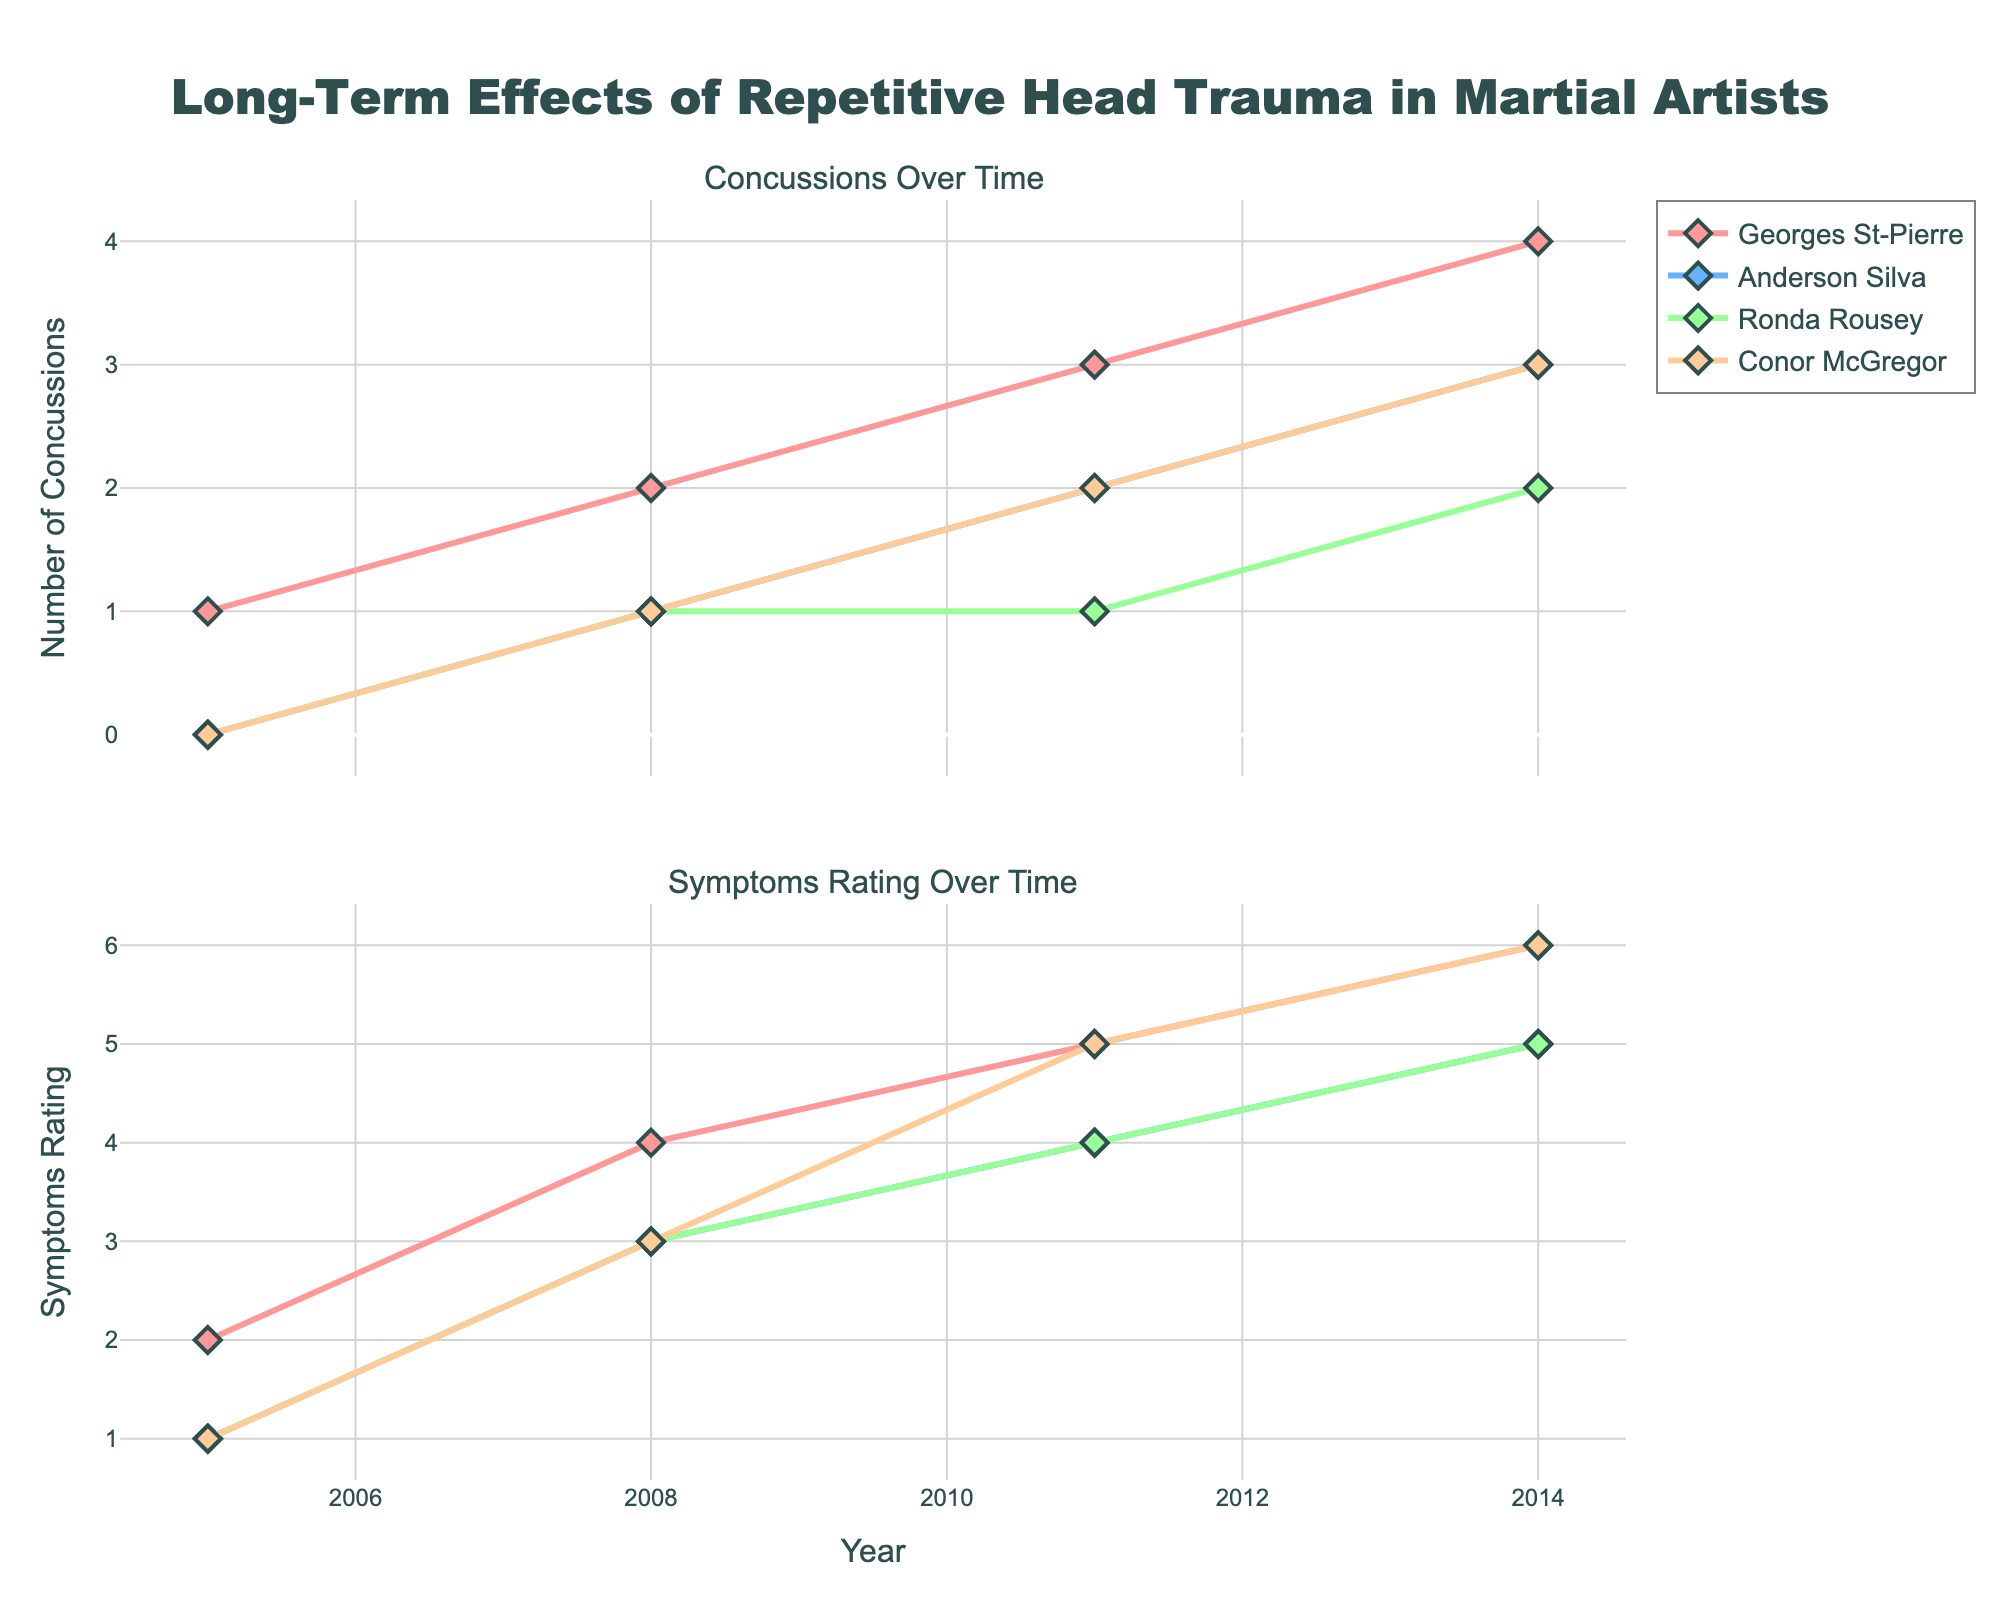What's the title of the figure? The title is usually displayed at the top of the figure. In this case, the title provided in the code is "Long-Term Effects of Repetitive Head Trauma in Martial Artists".
Answer: Long-Term Effects of Repetitive Head Trauma in Martial Artists How many concussions did Anderson Silva have in 2011? To answer this, locate Anderson Silva's data point for 2011 in the concussions plot. The value at 2011 for concussions is 2.
Answer: 2 What is the Symptoms Rating of Conor McGregor in 2011? To determine this, find the data point for Conor McGregor in the Symptoms Rating plot for the year 2011. The Symptoms Rating is 5.
Answer: 5 Which athlete shows an increase in concussions over every time period? Observe each athlete's trend lines in the concussions plot. Georges St-Pierre’s line consistently increases over every time period.
Answer: Georges St-Pierre How does Ronda Rousey's Symptoms Rating change from 2008 to 2011? Compare the Symptoms Rating values for Ronda Rousey between the years 2008 and 2011. Her rating increases from 3 to 4.
Answer: Increased from 3 to 4 Who had the highest Symptoms Rating in 2014? Look at the data points for all athletes in the Symptoms Rating plot for the year 2014. Conor McGregor has the highest rating with a value of 6.
Answer: Conor McGregor Which athlete experienced the biggest increase in concussions from 2005 to 2014? Calculate the difference in concussion values for each athlete between 2005 and 2014. Georges St-Pierre had the biggest increase, from 1 to 4.
Answer: Georges St-Pierre What was the trend in Anderson Silva's Symptoms Rating from 2005 to 2014? Examine the Symptoms Rating values for Anderson Silva over the given period. The values gradually increase from 1 in 2005 to 5 in 2014.
Answer: Gradually increased How many total concussions did Georges St-Pierre have by 2014? Sum the concussion values for Georges St-Pierre from all the provided years (1+2+3+4).
Answer: 10 Did any athlete show symptoms of CTE by 2014? Check the 2014 data for the Suspected CTE column. Georges St-Pierre and Conor McGregor show symptoms of CTE in 2014.
Answer: Georges St-Pierre, Conor McGregor 